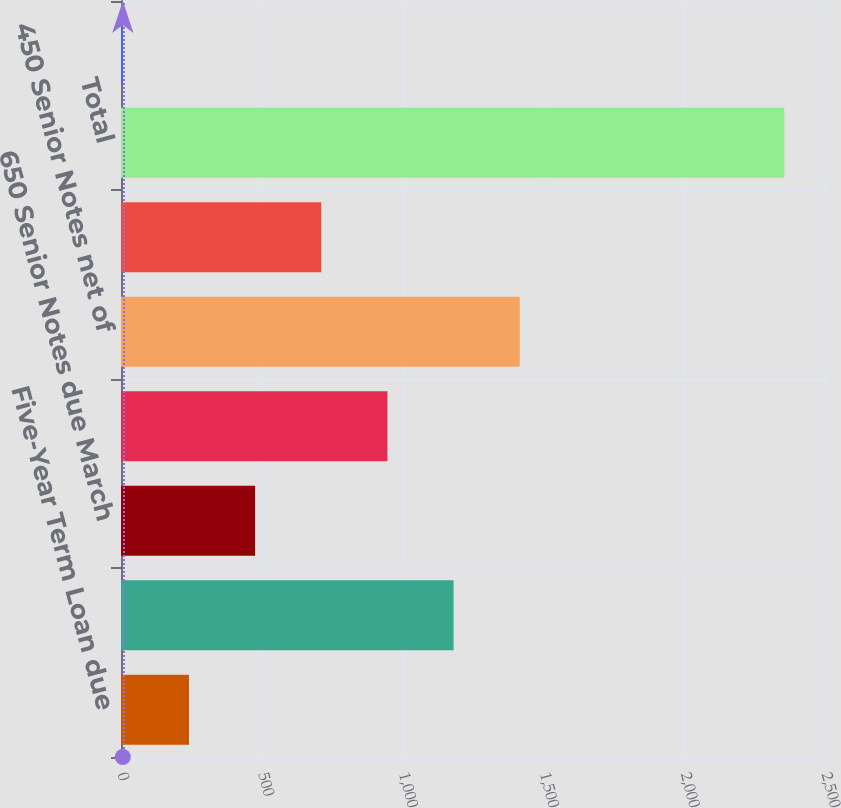Convert chart to OTSL. <chart><loc_0><loc_0><loc_500><loc_500><bar_chart><fcel>Five-Year Term Loan due<fcel>Seven-Year Term Loan due<fcel>650 Senior Notes due March<fcel>390 Senior Notes net of<fcel>450 Senior Notes net of<fcel>365 Senior Notes net of<fcel>Total<fcel>Less current portion<nl><fcel>241.39<fcel>1180.95<fcel>476.28<fcel>946.06<fcel>1415.84<fcel>711.17<fcel>2355.4<fcel>6.5<nl></chart> 